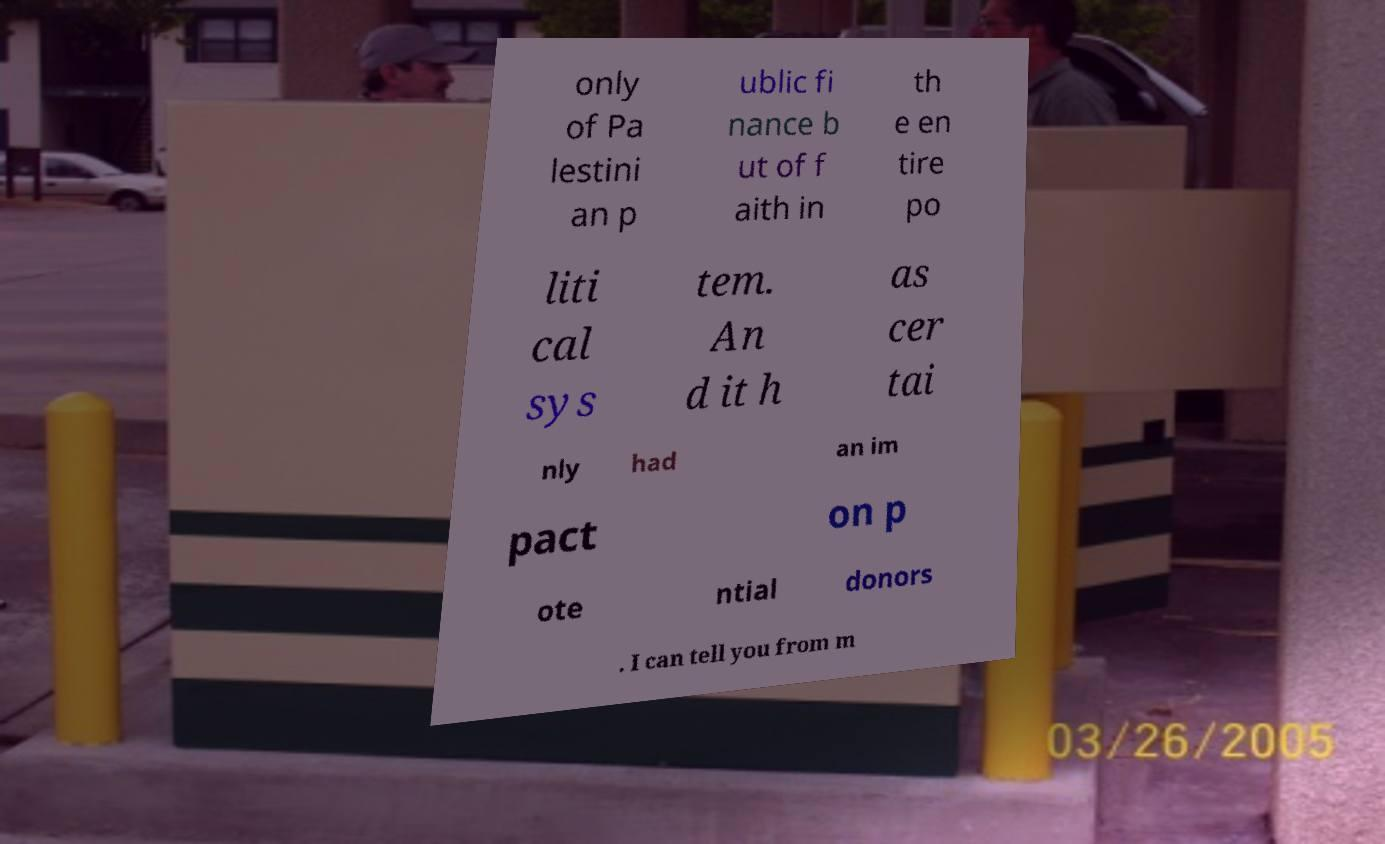Please read and relay the text visible in this image. What does it say? only of Pa lestini an p ublic fi nance b ut of f aith in th e en tire po liti cal sys tem. An d it h as cer tai nly had an im pact on p ote ntial donors . I can tell you from m 